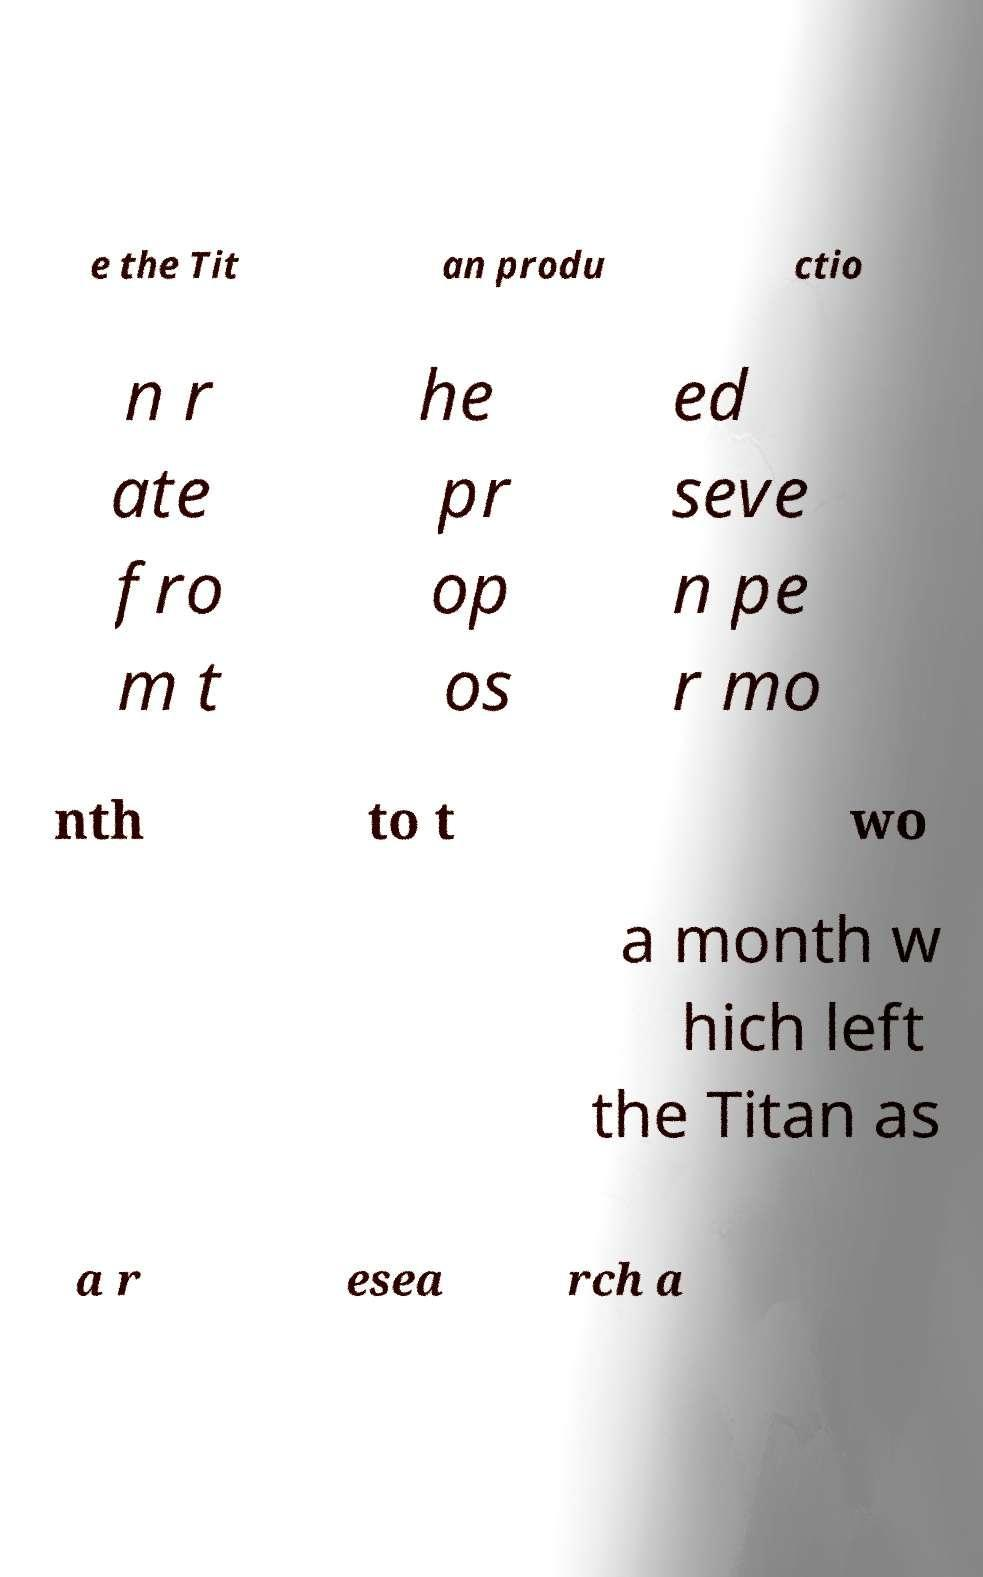Can you accurately transcribe the text from the provided image for me? e the Tit an produ ctio n r ate fro m t he pr op os ed seve n pe r mo nth to t wo a month w hich left the Titan as a r esea rch a 